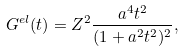<formula> <loc_0><loc_0><loc_500><loc_500>G ^ { e l } ( t ) = Z ^ { 2 } \frac { a ^ { 4 } t ^ { 2 } } { ( 1 + a ^ { 2 } t ^ { 2 } ) ^ { 2 } } ,</formula> 